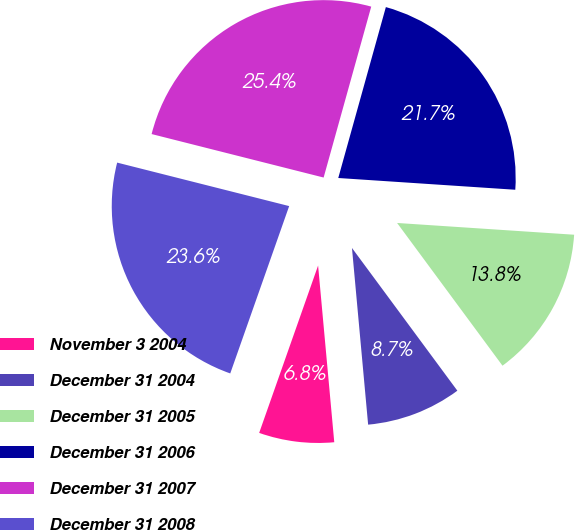Convert chart. <chart><loc_0><loc_0><loc_500><loc_500><pie_chart><fcel>November 3 2004<fcel>December 31 2004<fcel>December 31 2005<fcel>December 31 2006<fcel>December 31 2007<fcel>December 31 2008<nl><fcel>6.84%<fcel>8.67%<fcel>13.82%<fcel>21.73%<fcel>25.38%<fcel>23.55%<nl></chart> 